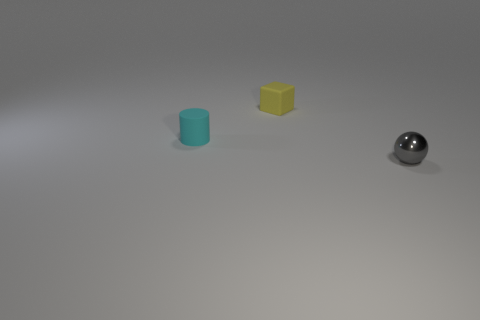Are the small cylinder and the tiny object right of the small yellow thing made of the same material?
Ensure brevity in your answer.  No. Do the small gray object and the tiny cyan object have the same shape?
Ensure brevity in your answer.  No. How many other objects are the same material as the tiny cylinder?
Your answer should be compact. 1. How many other things have the same shape as the small metallic object?
Provide a succinct answer. 0. What is the color of the tiny thing that is on the right side of the tiny cyan matte thing and in front of the small cube?
Ensure brevity in your answer.  Gray. What number of large cyan shiny objects are there?
Offer a terse response. 0. Does the gray sphere have the same size as the yellow matte cube?
Provide a succinct answer. Yes. Are there any large cylinders that have the same color as the small metal sphere?
Offer a terse response. No. There is a thing behind the tiny cylinder; is its shape the same as the small cyan rubber object?
Your answer should be very brief. No. What number of rubber objects have the same size as the gray metallic object?
Provide a short and direct response. 2. 